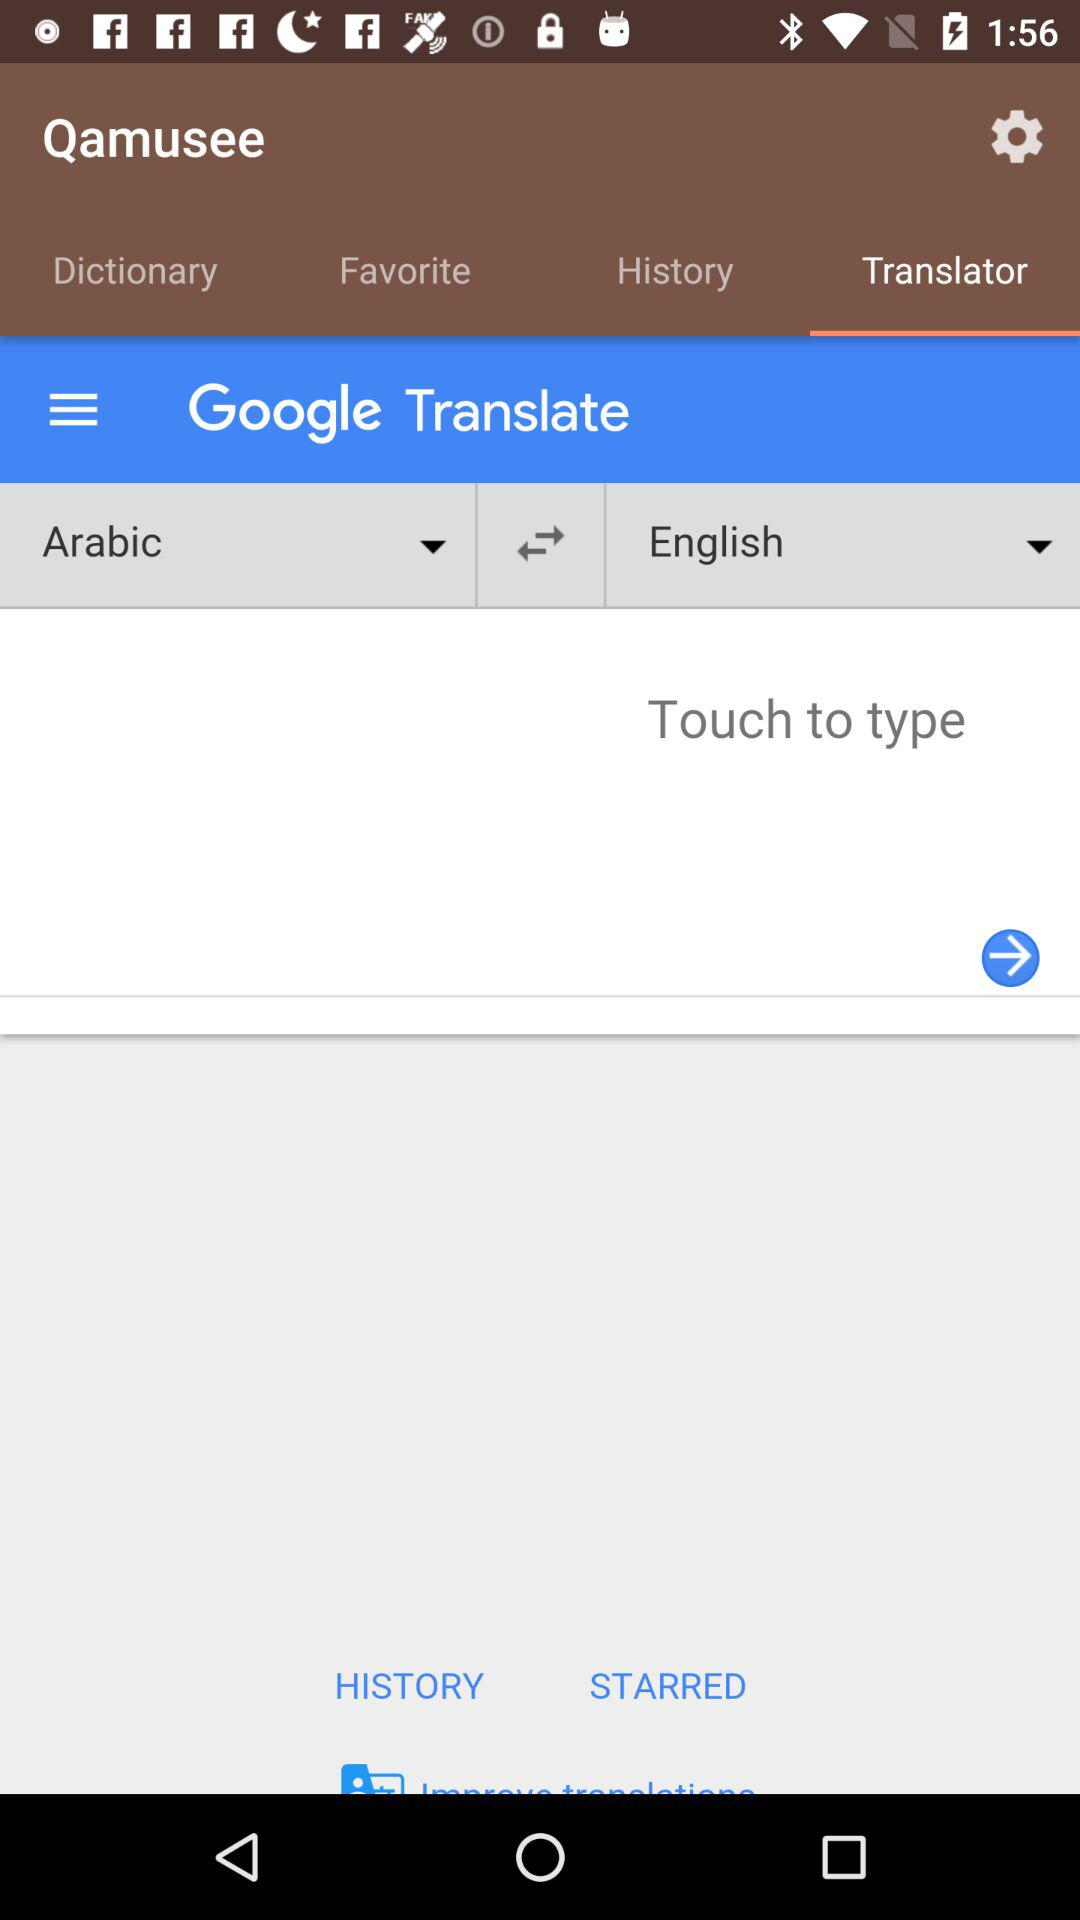From which language does Google translate to the English language? Google translates from the Arabic language to the English language. 